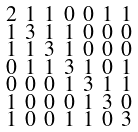<formula> <loc_0><loc_0><loc_500><loc_500>\begin{smallmatrix} 2 & 1 & 1 & 0 & 0 & 1 & 1 \\ 1 & 3 & 1 & 1 & 0 & 0 & 0 \\ 1 & 1 & 3 & 1 & 0 & 0 & 0 \\ 0 & 1 & 1 & 3 & 1 & 0 & 1 \\ 0 & 0 & 0 & 1 & 3 & 1 & 1 \\ 1 & 0 & 0 & 0 & 1 & 3 & 0 \\ 1 & 0 & 0 & 1 & 1 & 0 & 3 \end{smallmatrix}</formula> 